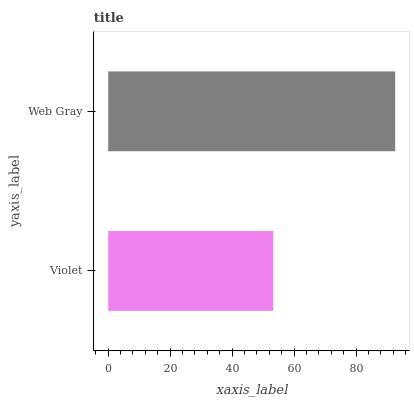Is Violet the minimum?
Answer yes or no. Yes. Is Web Gray the maximum?
Answer yes or no. Yes. Is Web Gray the minimum?
Answer yes or no. No. Is Web Gray greater than Violet?
Answer yes or no. Yes. Is Violet less than Web Gray?
Answer yes or no. Yes. Is Violet greater than Web Gray?
Answer yes or no. No. Is Web Gray less than Violet?
Answer yes or no. No. Is Web Gray the high median?
Answer yes or no. Yes. Is Violet the low median?
Answer yes or no. Yes. Is Violet the high median?
Answer yes or no. No. Is Web Gray the low median?
Answer yes or no. No. 